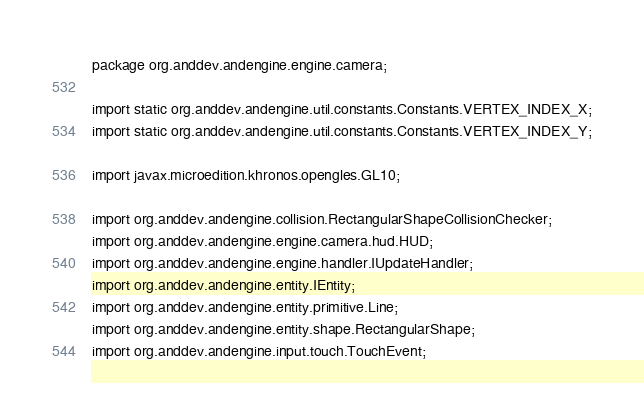<code> <loc_0><loc_0><loc_500><loc_500><_Java_>package org.anddev.andengine.engine.camera;

import static org.anddev.andengine.util.constants.Constants.VERTEX_INDEX_X;
import static org.anddev.andengine.util.constants.Constants.VERTEX_INDEX_Y;

import javax.microedition.khronos.opengles.GL10;

import org.anddev.andengine.collision.RectangularShapeCollisionChecker;
import org.anddev.andengine.engine.camera.hud.HUD;
import org.anddev.andengine.engine.handler.IUpdateHandler;
import org.anddev.andengine.entity.IEntity;
import org.anddev.andengine.entity.primitive.Line;
import org.anddev.andengine.entity.shape.RectangularShape;
import org.anddev.andengine.input.touch.TouchEvent;</code> 